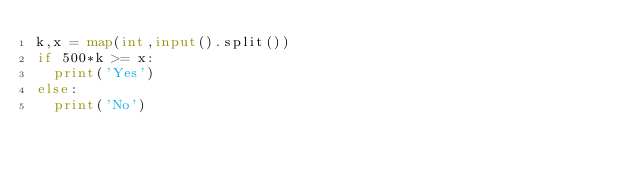<code> <loc_0><loc_0><loc_500><loc_500><_Python_>k,x = map(int,input().split())
if 500*k >= x:
  print('Yes')
else:
  print('No')</code> 